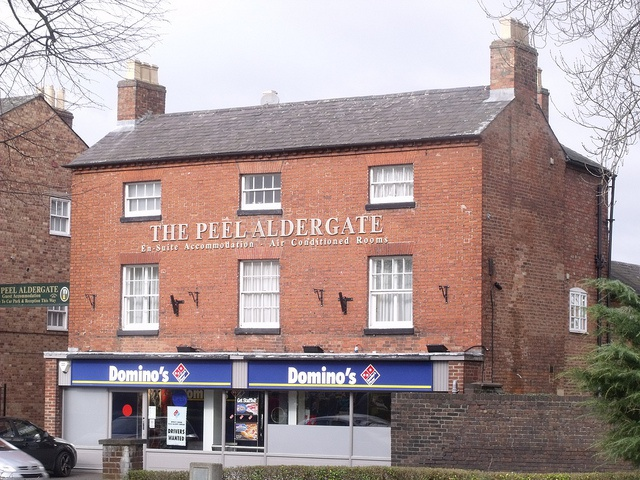Describe the objects in this image and their specific colors. I can see car in white, black, gray, and darkgray tones, car in white, darkgray, lavender, and gray tones, and car in white, gray, and black tones in this image. 